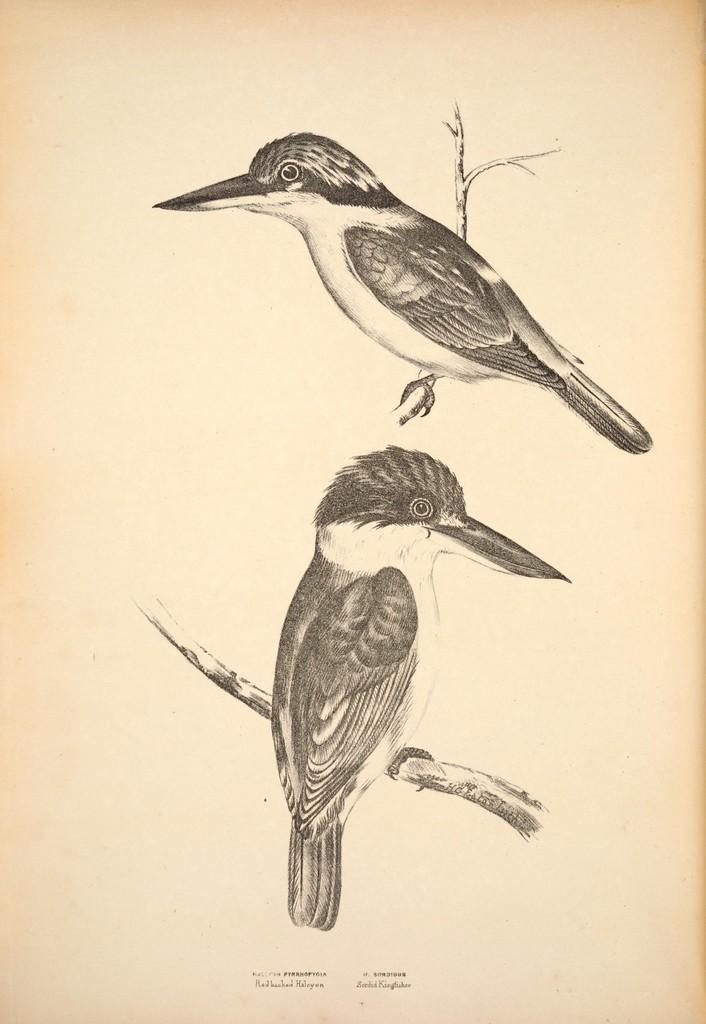What is the main subject in the center of the image? There is a paper in the center of the image. What is depicted on the paper? The paper has a drawing of two birds. What type of society is depicted in the drawing on the paper? The image does not depict a society; it has a drawing of two birds. Is there a party happening in the drawing on the paper? There is no indication of a party in the drawing on the paper; it features two birds. 